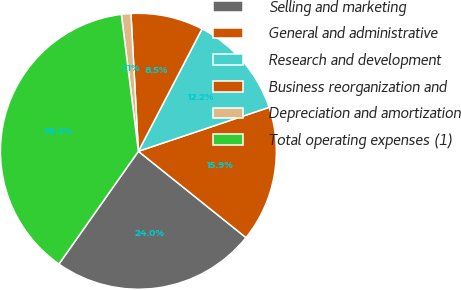Convert chart. <chart><loc_0><loc_0><loc_500><loc_500><pie_chart><fcel>Selling and marketing<fcel>General and administrative<fcel>Research and development<fcel>Business reorganization and<fcel>Depreciation and amortization<fcel>Total operating expenses (1)<nl><fcel>24.01%<fcel>15.92%<fcel>12.21%<fcel>8.49%<fcel>1.11%<fcel>38.26%<nl></chart> 